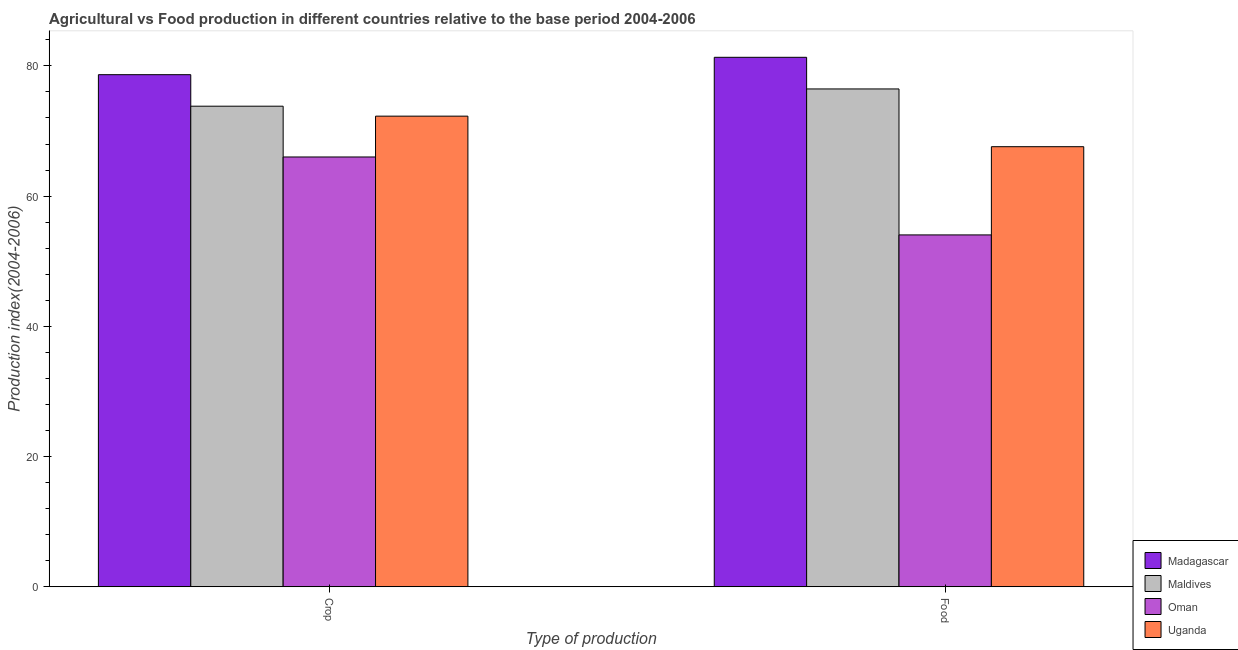Are the number of bars on each tick of the X-axis equal?
Offer a very short reply. Yes. How many bars are there on the 1st tick from the right?
Ensure brevity in your answer.  4. What is the label of the 2nd group of bars from the left?
Offer a terse response. Food. What is the crop production index in Uganda?
Give a very brief answer. 72.28. Across all countries, what is the maximum crop production index?
Make the answer very short. 78.65. Across all countries, what is the minimum food production index?
Give a very brief answer. 54.04. In which country was the crop production index maximum?
Offer a terse response. Madagascar. In which country was the crop production index minimum?
Ensure brevity in your answer.  Oman. What is the total food production index in the graph?
Provide a succinct answer. 279.41. What is the difference between the food production index in Uganda and that in Maldives?
Make the answer very short. -8.87. What is the difference between the food production index in Uganda and the crop production index in Madagascar?
Provide a succinct answer. -11.06. What is the average food production index per country?
Keep it short and to the point. 69.85. What is the difference between the crop production index and food production index in Oman?
Your response must be concise. 11.97. In how many countries, is the crop production index greater than 60 ?
Your answer should be very brief. 4. What is the ratio of the crop production index in Madagascar to that in Oman?
Your answer should be compact. 1.19. What does the 3rd bar from the left in Crop represents?
Offer a terse response. Oman. What does the 3rd bar from the right in Food represents?
Ensure brevity in your answer.  Maldives. How many bars are there?
Keep it short and to the point. 8. Does the graph contain grids?
Offer a very short reply. No. How many legend labels are there?
Give a very brief answer. 4. What is the title of the graph?
Provide a succinct answer. Agricultural vs Food production in different countries relative to the base period 2004-2006. What is the label or title of the X-axis?
Your answer should be compact. Type of production. What is the label or title of the Y-axis?
Your answer should be compact. Production index(2004-2006). What is the Production index(2004-2006) in Madagascar in Crop?
Ensure brevity in your answer.  78.65. What is the Production index(2004-2006) of Maldives in Crop?
Provide a succinct answer. 73.81. What is the Production index(2004-2006) in Oman in Crop?
Keep it short and to the point. 66.01. What is the Production index(2004-2006) in Uganda in Crop?
Give a very brief answer. 72.28. What is the Production index(2004-2006) in Madagascar in Food?
Ensure brevity in your answer.  81.32. What is the Production index(2004-2006) of Maldives in Food?
Your response must be concise. 76.46. What is the Production index(2004-2006) of Oman in Food?
Provide a short and direct response. 54.04. What is the Production index(2004-2006) in Uganda in Food?
Ensure brevity in your answer.  67.59. Across all Type of production, what is the maximum Production index(2004-2006) in Madagascar?
Keep it short and to the point. 81.32. Across all Type of production, what is the maximum Production index(2004-2006) in Maldives?
Offer a very short reply. 76.46. Across all Type of production, what is the maximum Production index(2004-2006) in Oman?
Your answer should be very brief. 66.01. Across all Type of production, what is the maximum Production index(2004-2006) in Uganda?
Your response must be concise. 72.28. Across all Type of production, what is the minimum Production index(2004-2006) of Madagascar?
Give a very brief answer. 78.65. Across all Type of production, what is the minimum Production index(2004-2006) of Maldives?
Make the answer very short. 73.81. Across all Type of production, what is the minimum Production index(2004-2006) in Oman?
Your response must be concise. 54.04. Across all Type of production, what is the minimum Production index(2004-2006) of Uganda?
Your answer should be very brief. 67.59. What is the total Production index(2004-2006) of Madagascar in the graph?
Give a very brief answer. 159.97. What is the total Production index(2004-2006) of Maldives in the graph?
Your response must be concise. 150.27. What is the total Production index(2004-2006) in Oman in the graph?
Your response must be concise. 120.05. What is the total Production index(2004-2006) of Uganda in the graph?
Provide a short and direct response. 139.87. What is the difference between the Production index(2004-2006) in Madagascar in Crop and that in Food?
Your answer should be very brief. -2.67. What is the difference between the Production index(2004-2006) in Maldives in Crop and that in Food?
Offer a very short reply. -2.65. What is the difference between the Production index(2004-2006) of Oman in Crop and that in Food?
Your answer should be compact. 11.97. What is the difference between the Production index(2004-2006) in Uganda in Crop and that in Food?
Your answer should be very brief. 4.69. What is the difference between the Production index(2004-2006) of Madagascar in Crop and the Production index(2004-2006) of Maldives in Food?
Provide a short and direct response. 2.19. What is the difference between the Production index(2004-2006) in Madagascar in Crop and the Production index(2004-2006) in Oman in Food?
Offer a terse response. 24.61. What is the difference between the Production index(2004-2006) of Madagascar in Crop and the Production index(2004-2006) of Uganda in Food?
Provide a short and direct response. 11.06. What is the difference between the Production index(2004-2006) of Maldives in Crop and the Production index(2004-2006) of Oman in Food?
Ensure brevity in your answer.  19.77. What is the difference between the Production index(2004-2006) of Maldives in Crop and the Production index(2004-2006) of Uganda in Food?
Offer a terse response. 6.22. What is the difference between the Production index(2004-2006) of Oman in Crop and the Production index(2004-2006) of Uganda in Food?
Your response must be concise. -1.58. What is the average Production index(2004-2006) in Madagascar per Type of production?
Keep it short and to the point. 79.98. What is the average Production index(2004-2006) in Maldives per Type of production?
Your answer should be compact. 75.14. What is the average Production index(2004-2006) of Oman per Type of production?
Offer a terse response. 60.02. What is the average Production index(2004-2006) in Uganda per Type of production?
Provide a succinct answer. 69.94. What is the difference between the Production index(2004-2006) in Madagascar and Production index(2004-2006) in Maldives in Crop?
Your answer should be compact. 4.84. What is the difference between the Production index(2004-2006) in Madagascar and Production index(2004-2006) in Oman in Crop?
Your answer should be compact. 12.64. What is the difference between the Production index(2004-2006) in Madagascar and Production index(2004-2006) in Uganda in Crop?
Give a very brief answer. 6.37. What is the difference between the Production index(2004-2006) in Maldives and Production index(2004-2006) in Oman in Crop?
Offer a very short reply. 7.8. What is the difference between the Production index(2004-2006) of Maldives and Production index(2004-2006) of Uganda in Crop?
Offer a very short reply. 1.53. What is the difference between the Production index(2004-2006) in Oman and Production index(2004-2006) in Uganda in Crop?
Provide a short and direct response. -6.27. What is the difference between the Production index(2004-2006) in Madagascar and Production index(2004-2006) in Maldives in Food?
Make the answer very short. 4.86. What is the difference between the Production index(2004-2006) of Madagascar and Production index(2004-2006) of Oman in Food?
Offer a terse response. 27.28. What is the difference between the Production index(2004-2006) of Madagascar and Production index(2004-2006) of Uganda in Food?
Give a very brief answer. 13.73. What is the difference between the Production index(2004-2006) of Maldives and Production index(2004-2006) of Oman in Food?
Provide a succinct answer. 22.42. What is the difference between the Production index(2004-2006) in Maldives and Production index(2004-2006) in Uganda in Food?
Ensure brevity in your answer.  8.87. What is the difference between the Production index(2004-2006) of Oman and Production index(2004-2006) of Uganda in Food?
Make the answer very short. -13.55. What is the ratio of the Production index(2004-2006) in Madagascar in Crop to that in Food?
Give a very brief answer. 0.97. What is the ratio of the Production index(2004-2006) of Maldives in Crop to that in Food?
Your answer should be compact. 0.97. What is the ratio of the Production index(2004-2006) in Oman in Crop to that in Food?
Offer a terse response. 1.22. What is the ratio of the Production index(2004-2006) in Uganda in Crop to that in Food?
Ensure brevity in your answer.  1.07. What is the difference between the highest and the second highest Production index(2004-2006) of Madagascar?
Provide a succinct answer. 2.67. What is the difference between the highest and the second highest Production index(2004-2006) in Maldives?
Give a very brief answer. 2.65. What is the difference between the highest and the second highest Production index(2004-2006) in Oman?
Provide a short and direct response. 11.97. What is the difference between the highest and the second highest Production index(2004-2006) of Uganda?
Your answer should be very brief. 4.69. What is the difference between the highest and the lowest Production index(2004-2006) of Madagascar?
Your answer should be compact. 2.67. What is the difference between the highest and the lowest Production index(2004-2006) of Maldives?
Offer a terse response. 2.65. What is the difference between the highest and the lowest Production index(2004-2006) of Oman?
Provide a short and direct response. 11.97. What is the difference between the highest and the lowest Production index(2004-2006) in Uganda?
Provide a succinct answer. 4.69. 